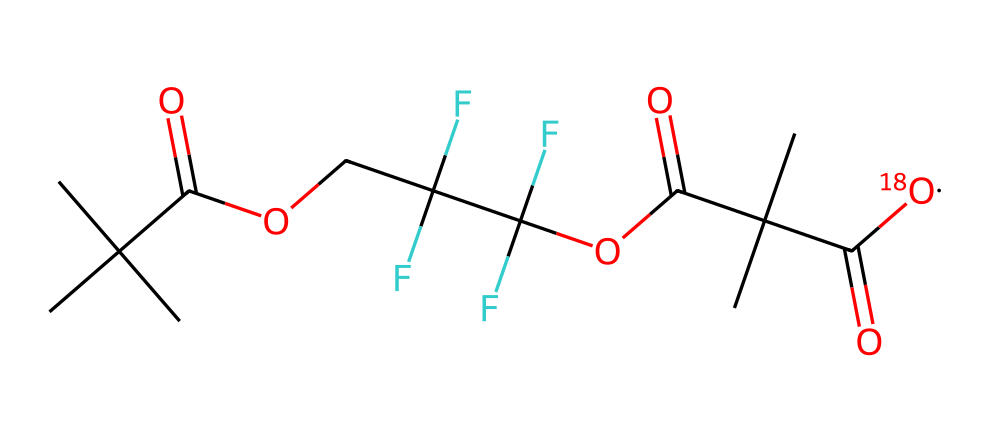What is the total number of carbon atoms in this molecule? By examining the SMILES representation, we can count the "C" symbols. In this case, there are 8 "C" symbols indicating 8 carbon atoms in total.
Answer: 8 How many fluorine atoms are present in this chemical? Looking for the "F" symbols in the SMILES, we find there are 6 "F" symbols present, which indicates 6 fluorine atoms in the structure.
Answer: 6 What functional groups are present in this molecule? Analyzing the SMILES structure reveals two functional groups: the carboxyl groups (C(=O)O) and the ether groups (C(F)(F)OC(=O)).
Answer: carboxyl and ether Why is the presence of the [18O] isotope significant? The [18O] indicates the presence of a heavier isotope of oxygen, which is used in various scientific studies to trace chemical pathways, especially in breathable membranes.
Answer: tracing chemical pathways What is the overall type of this molecule based on its structure? This molecule contains both oxygen isotopes and fluorinated compounds, suggesting it could be categorized as a perfluorinated ether or complex ester with isotopic labeling, commonly used in membranes.
Answer: perfluorinated ether How many hydrogen atoms are likely associated with this molecule considering the structure? Each carbon atom can potentially bond with hydrogen atoms, and considering the functional groups, we assess the structure and approximate that there would be around 13 hydrogen atoms adjusted for the functional groups present.
Answer: 13 